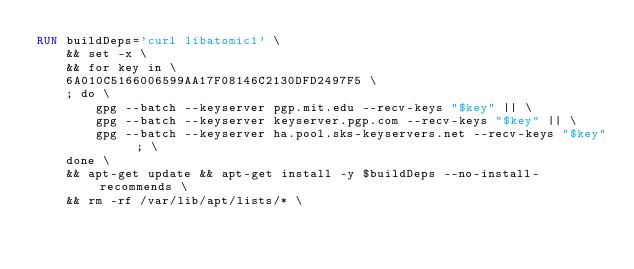<code> <loc_0><loc_0><loc_500><loc_500><_Dockerfile_>RUN buildDeps='curl libatomic1' \
	&& set -x \
	&& for key in \
	6A010C5166006599AA17F08146C2130DFD2497F5 \
	; do \
		gpg --batch --keyserver pgp.mit.edu --recv-keys "$key" || \
		gpg --batch --keyserver keyserver.pgp.com --recv-keys "$key" || \
		gpg --batch --keyserver ha.pool.sks-keyservers.net --recv-keys "$key" ; \
	done \
	&& apt-get update && apt-get install -y $buildDeps --no-install-recommends \
	&& rm -rf /var/lib/apt/lists/* \</code> 